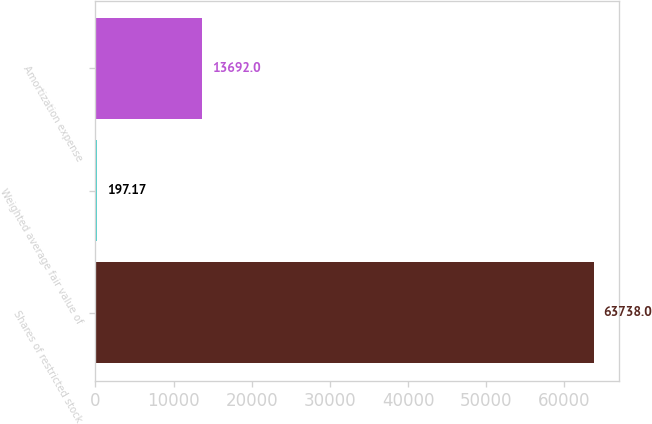Convert chart to OTSL. <chart><loc_0><loc_0><loc_500><loc_500><bar_chart><fcel>Shares of restricted stock<fcel>Weighted average fair value of<fcel>Amortization expense<nl><fcel>63738<fcel>197.17<fcel>13692<nl></chart> 